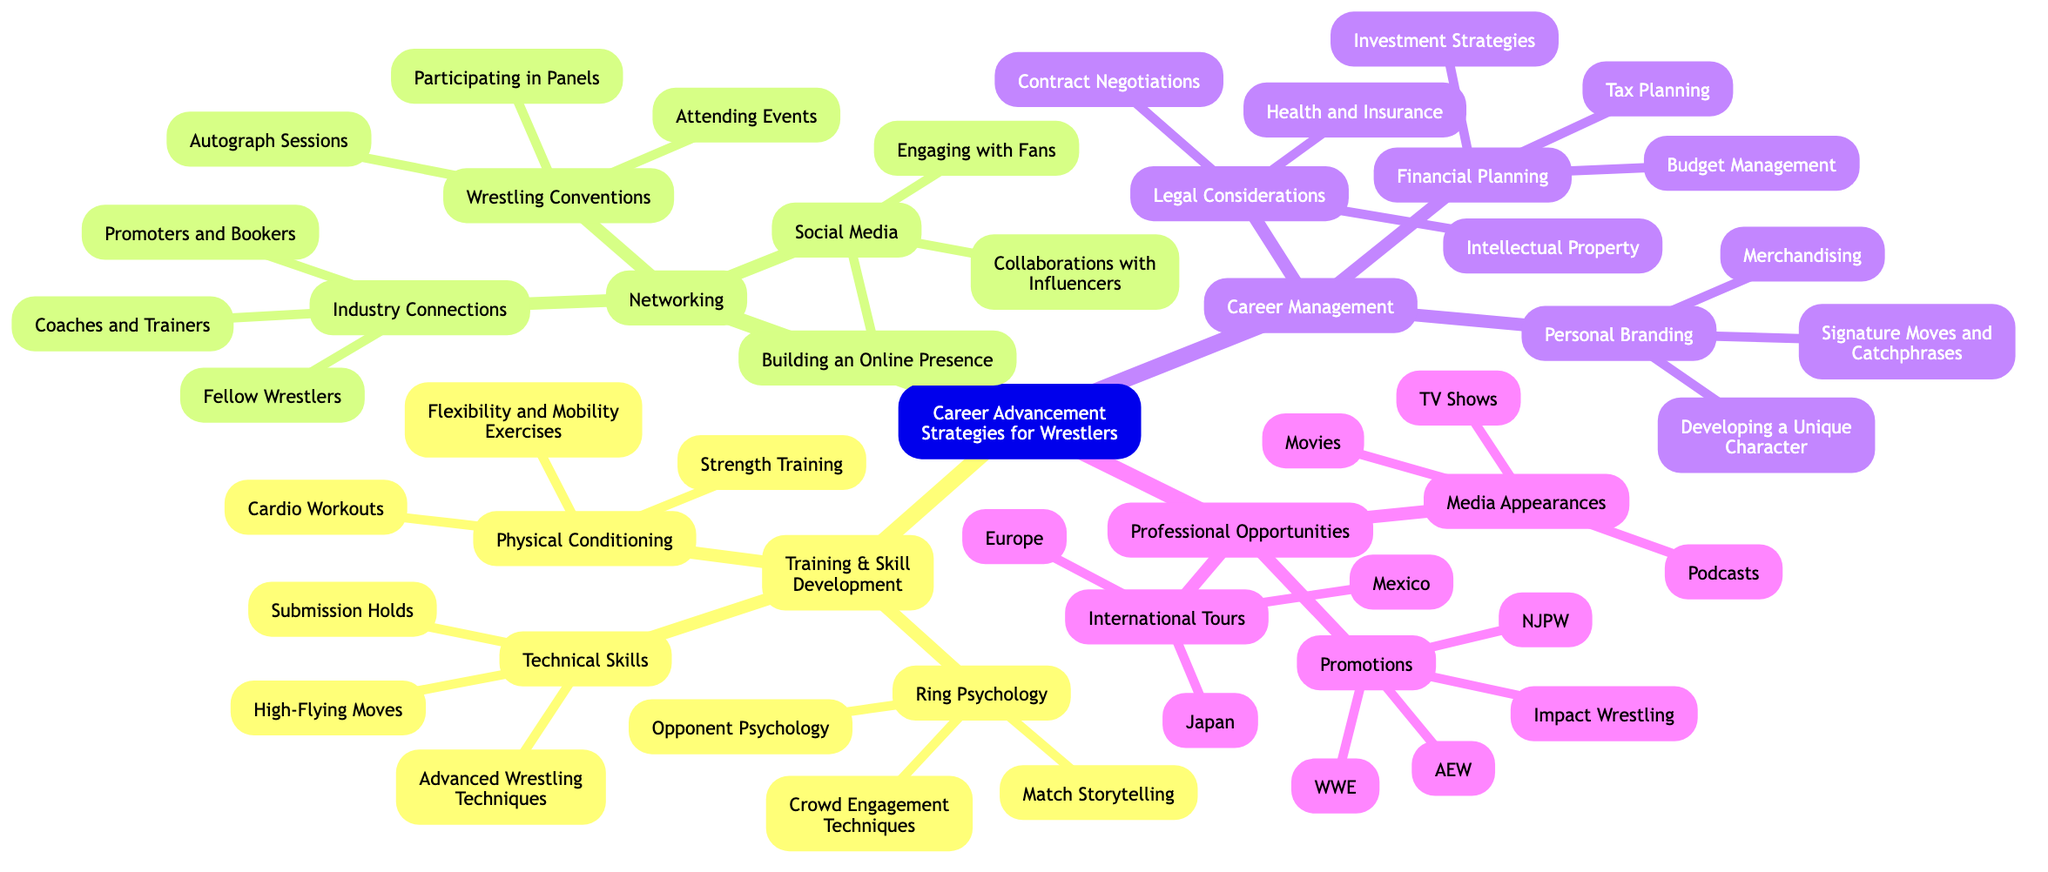What are the three main categories of career advancement strategies for wrestlers? The diagram shows four main categories: Training & Skill Development, Networking, Career Management, and Professional Opportunities.
Answer: Training & Skill Development, Networking, Career Management, Professional Opportunities How many technical skill development areas are listed? The diagram indicates that there are three areas under Technical Skills: Advanced Wrestling Techniques, Submission Holds, and High-Flying Moves.
Answer: 3 What is one financial planning aspect mentioned in career management? The diagram lists three components under Financial Planning, including Budget Management, Investment Strategies, and Tax Planning. Any one of them, like Budget Management, would be correct.
Answer: Budget Management Which international tour locations are mentioned? The diagram defines three distinct regions under International Tours: Japan, Mexico, and Europe. Therefore, any of these can be considered.
Answer: Japan, Mexico, Europe Which professional wrestling promotions are noted in the opportunities section? The diagram outlines four promotions: WWE, AEW, NJPW, and Impact Wrestling, thus highlighting these as professional opportunities for wrestlers.
Answer: WWE, AEW, NJPW, Impact Wrestling What type of social media activity is suggested for networking? The section on Social Media includes three activities: Building an Online Presence, Engaging with Fans, and Collaborations with Influencers. Any of these represent suggested activities.
Answer: Building an Online Presence How many elements are listed under Ring Psychology? There are three important aspects listed under Ring Psychology: Match Storytelling, Opponent Psychology, and Crowd Engagement Techniques, summing up to three elements.
Answer: 3 Which aspect of career management involves developing a unique character? The diagram categorizes Personal Branding under Career Management, which includes Developing a Unique Character as a specific element.
Answer: Personal Branding What element under Professional Opportunities focuses on media exposure? The Media Appearances section mentions three types, including TV Shows, Movies, and Podcasts, addressing this aspect of professional opportunities.
Answer: Media Appearances 